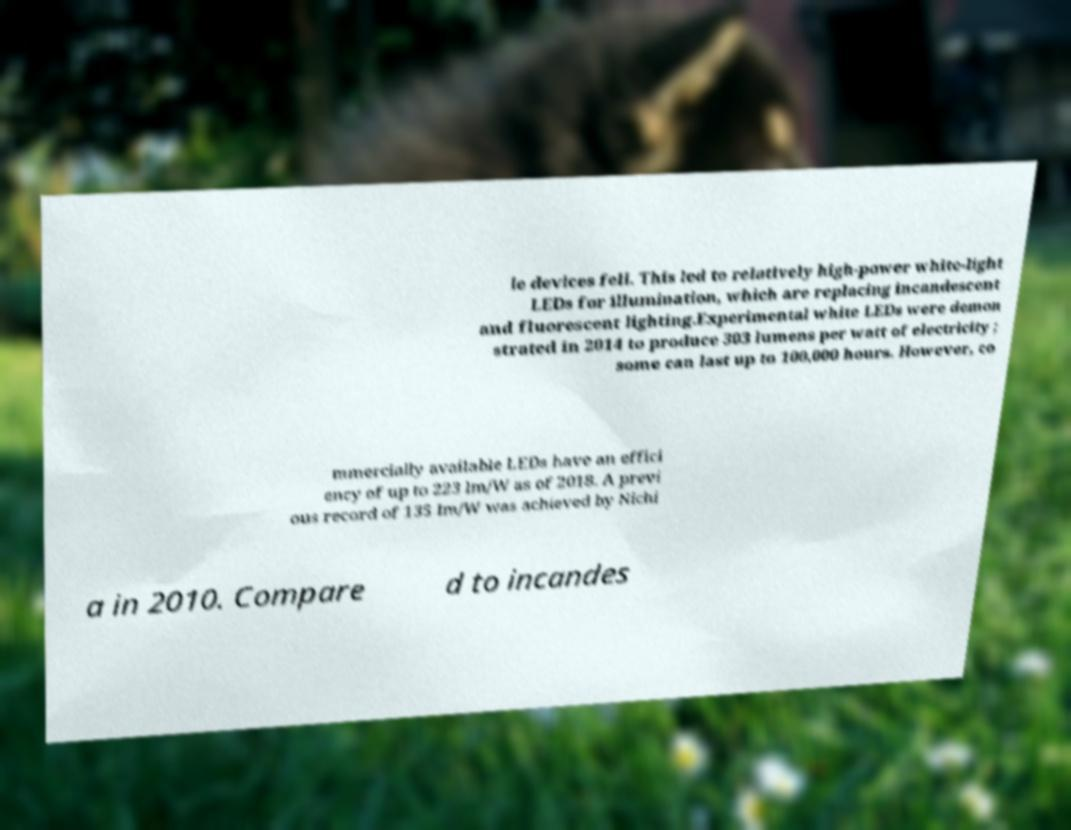What messages or text are displayed in this image? I need them in a readable, typed format. le devices fell. This led to relatively high-power white-light LEDs for illumination, which are replacing incandescent and fluorescent lighting.Experimental white LEDs were demon strated in 2014 to produce 303 lumens per watt of electricity ; some can last up to 100,000 hours. However, co mmercially available LEDs have an effici ency of up to 223 lm/W as of 2018. A previ ous record of 135 lm/W was achieved by Nichi a in 2010. Compare d to incandes 